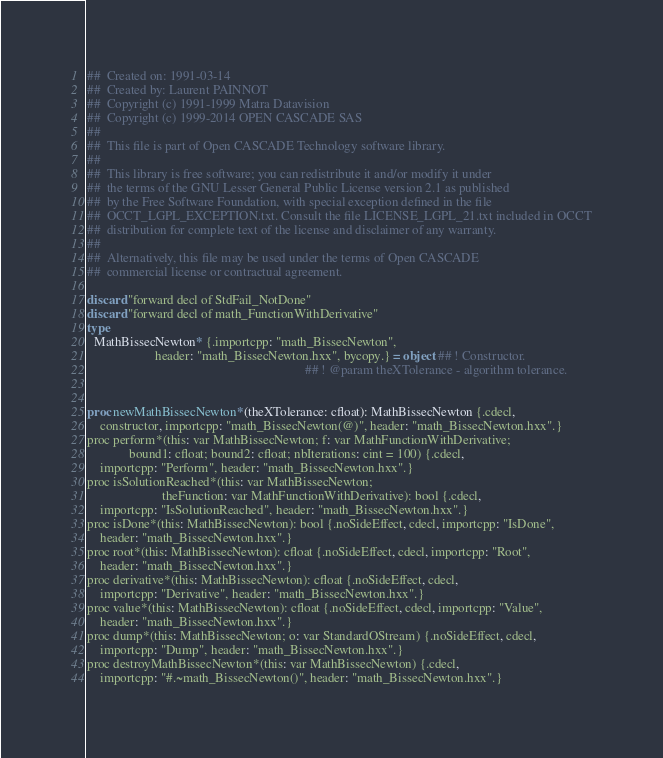Convert code to text. <code><loc_0><loc_0><loc_500><loc_500><_Nim_>##  Created on: 1991-03-14
##  Created by: Laurent PAINNOT
##  Copyright (c) 1991-1999 Matra Datavision
##  Copyright (c) 1999-2014 OPEN CASCADE SAS
##
##  This file is part of Open CASCADE Technology software library.
##
##  This library is free software; you can redistribute it and/or modify it under
##  the terms of the GNU Lesser General Public License version 2.1 as published
##  by the Free Software Foundation, with special exception defined in the file
##  OCCT_LGPL_EXCEPTION.txt. Consult the file LICENSE_LGPL_21.txt included in OCCT
##  distribution for complete text of the license and disclaimer of any warranty.
##
##  Alternatively, this file may be used under the terms of Open CASCADE
##  commercial license or contractual agreement.

discard "forward decl of StdFail_NotDone"
discard "forward decl of math_FunctionWithDerivative"
type
  MathBissecNewton* {.importcpp: "math_BissecNewton",
                     header: "math_BissecNewton.hxx", bycopy.} = object ## ! Constructor.
                                                                   ## ! @param theXTolerance - algorithm tolerance.


proc newMathBissecNewton*(theXTolerance: cfloat): MathBissecNewton {.cdecl,
    constructor, importcpp: "math_BissecNewton(@)", header: "math_BissecNewton.hxx".}
proc perform*(this: var MathBissecNewton; f: var MathFunctionWithDerivative;
             bound1: cfloat; bound2: cfloat; nbIterations: cint = 100) {.cdecl,
    importcpp: "Perform", header: "math_BissecNewton.hxx".}
proc isSolutionReached*(this: var MathBissecNewton;
                       theFunction: var MathFunctionWithDerivative): bool {.cdecl,
    importcpp: "IsSolutionReached", header: "math_BissecNewton.hxx".}
proc isDone*(this: MathBissecNewton): bool {.noSideEffect, cdecl, importcpp: "IsDone",
    header: "math_BissecNewton.hxx".}
proc root*(this: MathBissecNewton): cfloat {.noSideEffect, cdecl, importcpp: "Root",
    header: "math_BissecNewton.hxx".}
proc derivative*(this: MathBissecNewton): cfloat {.noSideEffect, cdecl,
    importcpp: "Derivative", header: "math_BissecNewton.hxx".}
proc value*(this: MathBissecNewton): cfloat {.noSideEffect, cdecl, importcpp: "Value",
    header: "math_BissecNewton.hxx".}
proc dump*(this: MathBissecNewton; o: var StandardOStream) {.noSideEffect, cdecl,
    importcpp: "Dump", header: "math_BissecNewton.hxx".}
proc destroyMathBissecNewton*(this: var MathBissecNewton) {.cdecl,
    importcpp: "#.~math_BissecNewton()", header: "math_BissecNewton.hxx".}</code> 